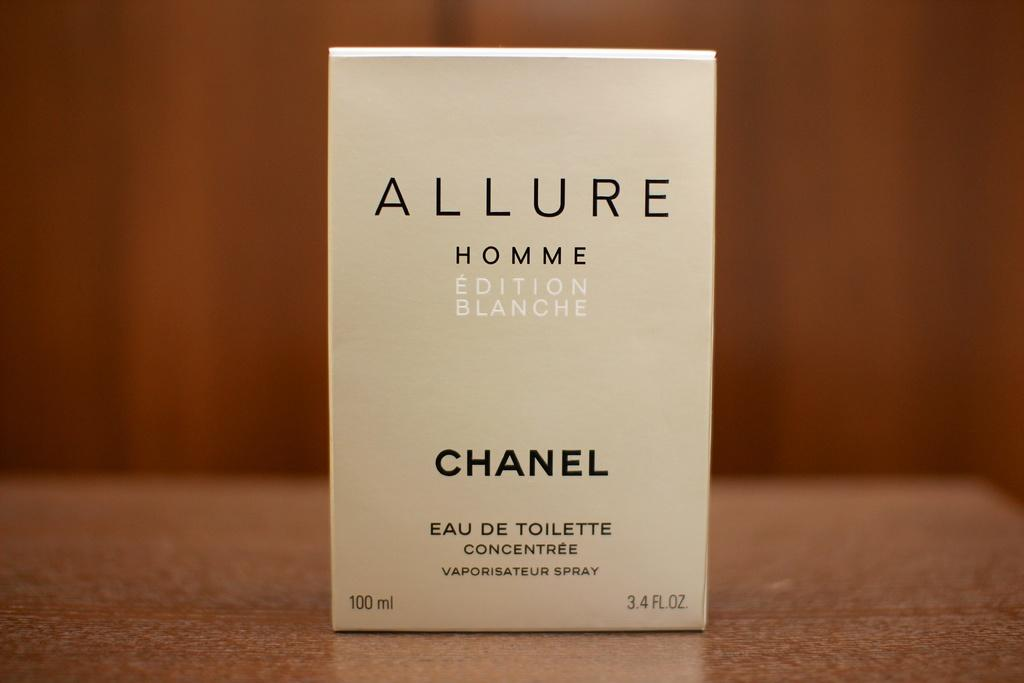<image>
Present a compact description of the photo's key features. a close up of a box for Allure Homme by Chanel 